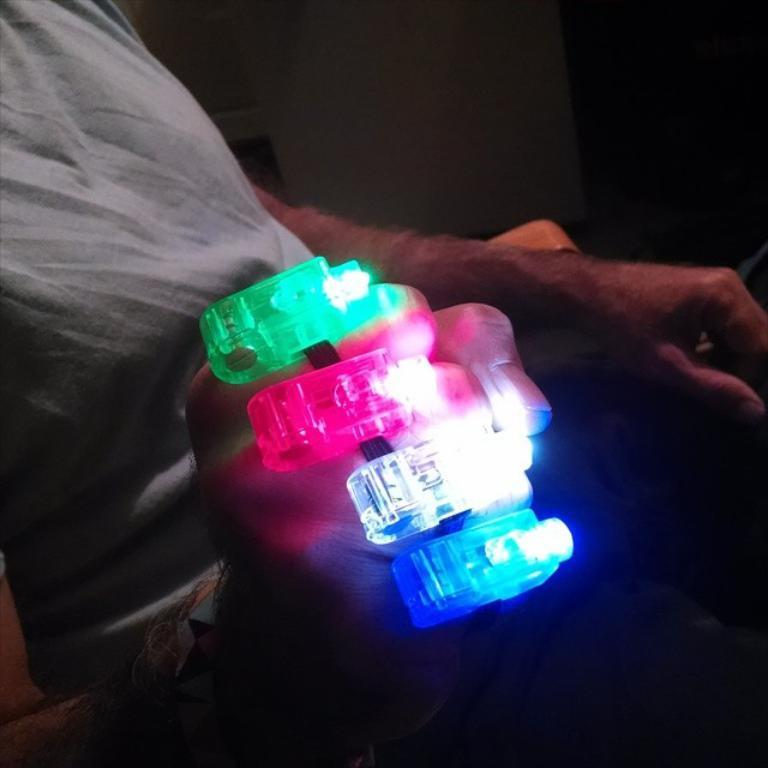What is the person in the image doing? The person is sitting on a chair in the image. What is the person holding in the image? The person is holding an object with lights. What can be seen in the background of the image? There is a wall in the background of the image. How does the person's digestion process appear in the image? There is no indication of the person's digestion process in the image. 